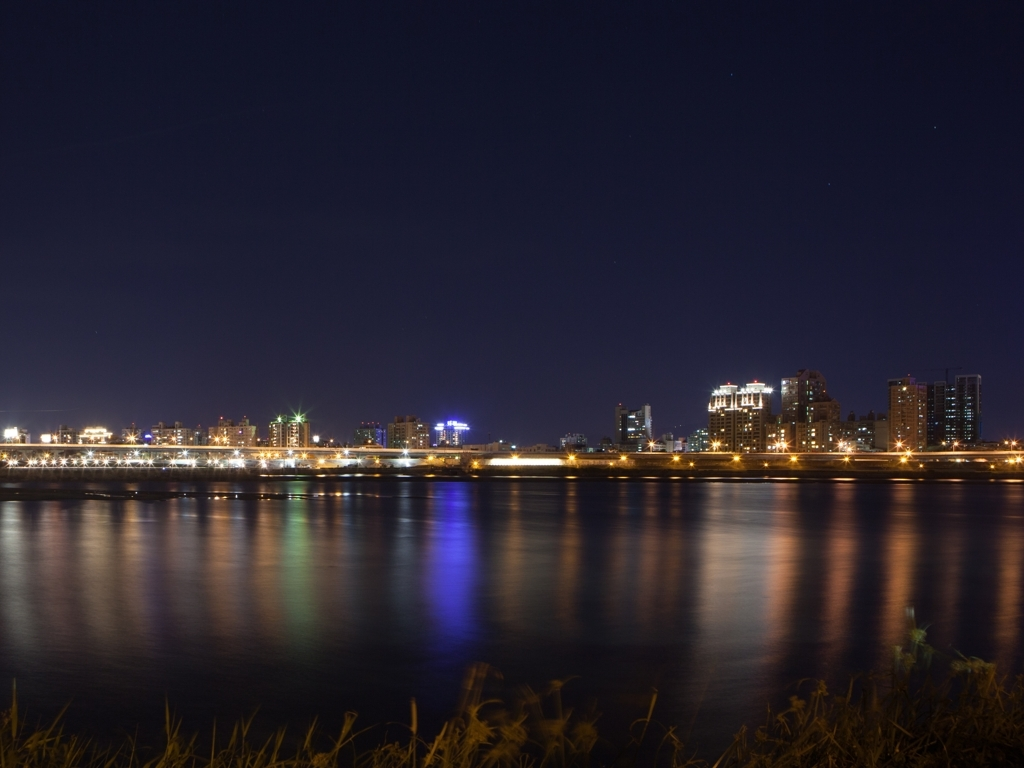What is the best feature of this night photograph? The best feature of this night photograph is its ability to capture the brilliant array of city lights reflecting off the water's surface, creating a vibrant and mesmerizing display of colors. 